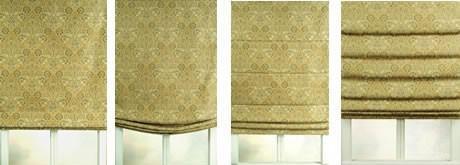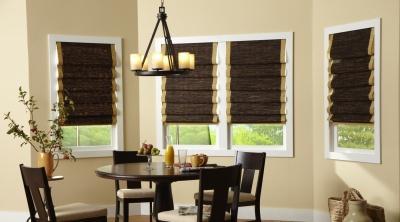The first image is the image on the left, the second image is the image on the right. Analyze the images presented: Is the assertion "One of the images shows windows and curtains with no surrounding room." valid? Answer yes or no. Yes. The first image is the image on the left, the second image is the image on the right. Assess this claim about the two images: "The left and right image contains the same number of blinds.". Correct or not? Answer yes or no. Yes. 